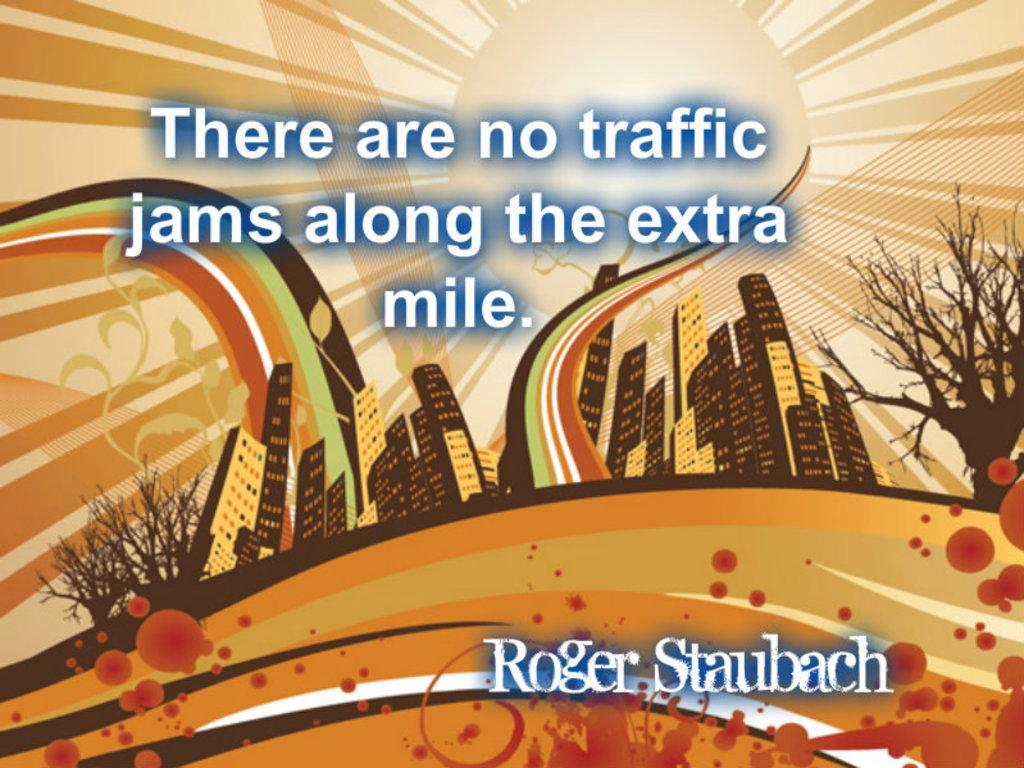What is present in the image that features images? There is a poster in the image that contains images. What type of images can be seen on the poster? The images on the poster are of buildings. Is there any text on the poster? Yes, there is text on the poster. Is there a veil covering the images on the poster? No, there is no veil present in the image. How many fans can be seen on the poster? There are no fans depicted on the poster; it features images of buildings and text. 